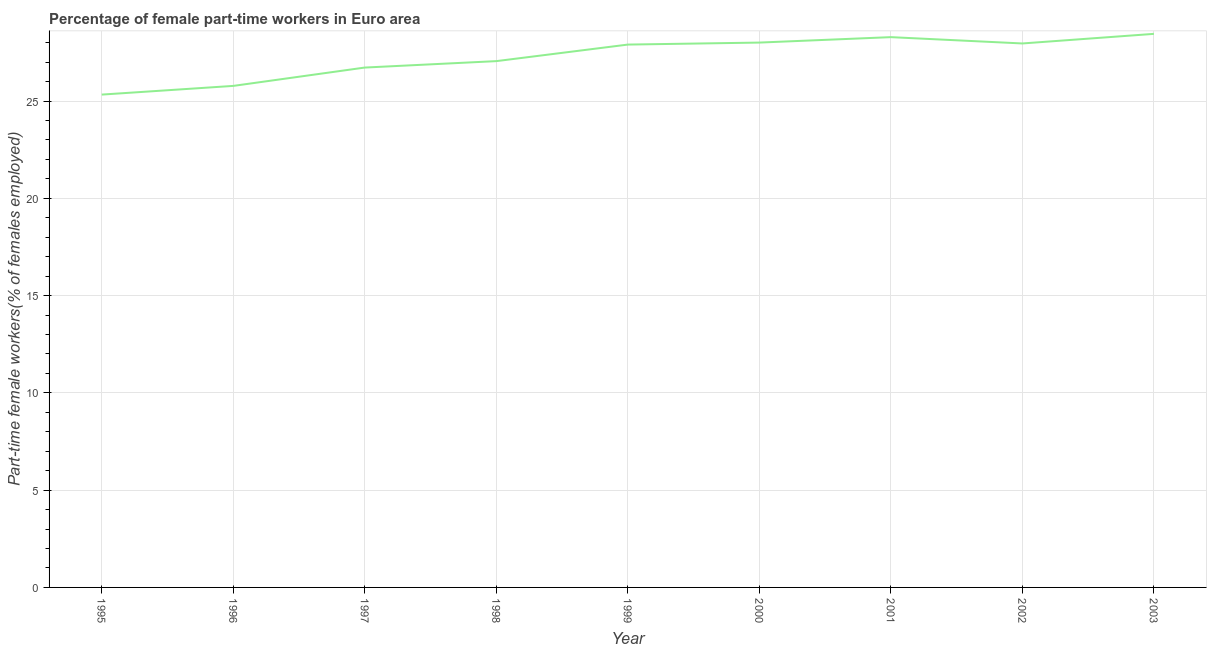What is the percentage of part-time female workers in 2003?
Your response must be concise. 28.45. Across all years, what is the maximum percentage of part-time female workers?
Provide a succinct answer. 28.45. Across all years, what is the minimum percentage of part-time female workers?
Make the answer very short. 25.33. In which year was the percentage of part-time female workers minimum?
Provide a succinct answer. 1995. What is the sum of the percentage of part-time female workers?
Offer a terse response. 245.49. What is the difference between the percentage of part-time female workers in 1999 and 2000?
Offer a very short reply. -0.1. What is the average percentage of part-time female workers per year?
Provide a succinct answer. 27.28. What is the median percentage of part-time female workers?
Offer a very short reply. 27.9. What is the ratio of the percentage of part-time female workers in 2001 to that in 2002?
Keep it short and to the point. 1.01. What is the difference between the highest and the second highest percentage of part-time female workers?
Keep it short and to the point. 0.17. What is the difference between the highest and the lowest percentage of part-time female workers?
Your response must be concise. 3.12. In how many years, is the percentage of part-time female workers greater than the average percentage of part-time female workers taken over all years?
Ensure brevity in your answer.  5. Does the percentage of part-time female workers monotonically increase over the years?
Your answer should be very brief. No. Does the graph contain any zero values?
Ensure brevity in your answer.  No. Does the graph contain grids?
Offer a very short reply. Yes. What is the title of the graph?
Offer a very short reply. Percentage of female part-time workers in Euro area. What is the label or title of the X-axis?
Your answer should be compact. Year. What is the label or title of the Y-axis?
Your answer should be compact. Part-time female workers(% of females employed). What is the Part-time female workers(% of females employed) of 1995?
Ensure brevity in your answer.  25.33. What is the Part-time female workers(% of females employed) in 1996?
Your answer should be very brief. 25.78. What is the Part-time female workers(% of females employed) of 1997?
Offer a terse response. 26.72. What is the Part-time female workers(% of females employed) in 1998?
Provide a short and direct response. 27.05. What is the Part-time female workers(% of females employed) of 1999?
Your answer should be compact. 27.9. What is the Part-time female workers(% of females employed) in 2000?
Your response must be concise. 28.01. What is the Part-time female workers(% of females employed) of 2001?
Ensure brevity in your answer.  28.28. What is the Part-time female workers(% of females employed) of 2002?
Offer a very short reply. 27.96. What is the Part-time female workers(% of females employed) of 2003?
Your response must be concise. 28.45. What is the difference between the Part-time female workers(% of females employed) in 1995 and 1996?
Your answer should be compact. -0.45. What is the difference between the Part-time female workers(% of females employed) in 1995 and 1997?
Your answer should be compact. -1.39. What is the difference between the Part-time female workers(% of females employed) in 1995 and 1998?
Provide a succinct answer. -1.72. What is the difference between the Part-time female workers(% of females employed) in 1995 and 1999?
Provide a succinct answer. -2.57. What is the difference between the Part-time female workers(% of females employed) in 1995 and 2000?
Your response must be concise. -2.67. What is the difference between the Part-time female workers(% of females employed) in 1995 and 2001?
Your answer should be compact. -2.95. What is the difference between the Part-time female workers(% of females employed) in 1995 and 2002?
Offer a very short reply. -2.63. What is the difference between the Part-time female workers(% of females employed) in 1995 and 2003?
Offer a very short reply. -3.12. What is the difference between the Part-time female workers(% of females employed) in 1996 and 1997?
Provide a succinct answer. -0.94. What is the difference between the Part-time female workers(% of females employed) in 1996 and 1998?
Your answer should be very brief. -1.27. What is the difference between the Part-time female workers(% of females employed) in 1996 and 1999?
Ensure brevity in your answer.  -2.12. What is the difference between the Part-time female workers(% of females employed) in 1996 and 2000?
Keep it short and to the point. -2.23. What is the difference between the Part-time female workers(% of females employed) in 1996 and 2001?
Provide a short and direct response. -2.51. What is the difference between the Part-time female workers(% of females employed) in 1996 and 2002?
Provide a short and direct response. -2.18. What is the difference between the Part-time female workers(% of females employed) in 1996 and 2003?
Offer a very short reply. -2.67. What is the difference between the Part-time female workers(% of females employed) in 1997 and 1998?
Ensure brevity in your answer.  -0.33. What is the difference between the Part-time female workers(% of females employed) in 1997 and 1999?
Provide a succinct answer. -1.18. What is the difference between the Part-time female workers(% of females employed) in 1997 and 2000?
Offer a terse response. -1.28. What is the difference between the Part-time female workers(% of females employed) in 1997 and 2001?
Make the answer very short. -1.56. What is the difference between the Part-time female workers(% of females employed) in 1997 and 2002?
Give a very brief answer. -1.24. What is the difference between the Part-time female workers(% of females employed) in 1997 and 2003?
Provide a succinct answer. -1.73. What is the difference between the Part-time female workers(% of females employed) in 1998 and 1999?
Keep it short and to the point. -0.85. What is the difference between the Part-time female workers(% of females employed) in 1998 and 2000?
Provide a succinct answer. -0.95. What is the difference between the Part-time female workers(% of females employed) in 1998 and 2001?
Your answer should be very brief. -1.23. What is the difference between the Part-time female workers(% of females employed) in 1998 and 2002?
Offer a terse response. -0.91. What is the difference between the Part-time female workers(% of females employed) in 1998 and 2003?
Keep it short and to the point. -1.4. What is the difference between the Part-time female workers(% of females employed) in 1999 and 2000?
Ensure brevity in your answer.  -0.1. What is the difference between the Part-time female workers(% of females employed) in 1999 and 2001?
Your answer should be compact. -0.38. What is the difference between the Part-time female workers(% of females employed) in 1999 and 2002?
Keep it short and to the point. -0.06. What is the difference between the Part-time female workers(% of females employed) in 1999 and 2003?
Your answer should be compact. -0.55. What is the difference between the Part-time female workers(% of females employed) in 2000 and 2001?
Make the answer very short. -0.28. What is the difference between the Part-time female workers(% of females employed) in 2000 and 2002?
Offer a terse response. 0.05. What is the difference between the Part-time female workers(% of females employed) in 2000 and 2003?
Offer a very short reply. -0.45. What is the difference between the Part-time female workers(% of females employed) in 2001 and 2002?
Make the answer very short. 0.33. What is the difference between the Part-time female workers(% of females employed) in 2001 and 2003?
Your answer should be compact. -0.17. What is the difference between the Part-time female workers(% of females employed) in 2002 and 2003?
Make the answer very short. -0.49. What is the ratio of the Part-time female workers(% of females employed) in 1995 to that in 1996?
Make the answer very short. 0.98. What is the ratio of the Part-time female workers(% of females employed) in 1995 to that in 1997?
Provide a short and direct response. 0.95. What is the ratio of the Part-time female workers(% of females employed) in 1995 to that in 1998?
Ensure brevity in your answer.  0.94. What is the ratio of the Part-time female workers(% of females employed) in 1995 to that in 1999?
Your response must be concise. 0.91. What is the ratio of the Part-time female workers(% of females employed) in 1995 to that in 2000?
Ensure brevity in your answer.  0.91. What is the ratio of the Part-time female workers(% of females employed) in 1995 to that in 2001?
Provide a succinct answer. 0.9. What is the ratio of the Part-time female workers(% of females employed) in 1995 to that in 2002?
Offer a very short reply. 0.91. What is the ratio of the Part-time female workers(% of females employed) in 1995 to that in 2003?
Offer a very short reply. 0.89. What is the ratio of the Part-time female workers(% of females employed) in 1996 to that in 1997?
Your answer should be compact. 0.96. What is the ratio of the Part-time female workers(% of females employed) in 1996 to that in 1998?
Provide a short and direct response. 0.95. What is the ratio of the Part-time female workers(% of females employed) in 1996 to that in 1999?
Provide a short and direct response. 0.92. What is the ratio of the Part-time female workers(% of females employed) in 1996 to that in 2000?
Provide a succinct answer. 0.92. What is the ratio of the Part-time female workers(% of females employed) in 1996 to that in 2001?
Your answer should be compact. 0.91. What is the ratio of the Part-time female workers(% of females employed) in 1996 to that in 2002?
Offer a terse response. 0.92. What is the ratio of the Part-time female workers(% of females employed) in 1996 to that in 2003?
Offer a terse response. 0.91. What is the ratio of the Part-time female workers(% of females employed) in 1997 to that in 1998?
Provide a short and direct response. 0.99. What is the ratio of the Part-time female workers(% of females employed) in 1997 to that in 1999?
Provide a succinct answer. 0.96. What is the ratio of the Part-time female workers(% of females employed) in 1997 to that in 2000?
Your response must be concise. 0.95. What is the ratio of the Part-time female workers(% of females employed) in 1997 to that in 2001?
Ensure brevity in your answer.  0.94. What is the ratio of the Part-time female workers(% of females employed) in 1997 to that in 2002?
Make the answer very short. 0.96. What is the ratio of the Part-time female workers(% of females employed) in 1997 to that in 2003?
Your response must be concise. 0.94. What is the ratio of the Part-time female workers(% of females employed) in 1998 to that in 2000?
Keep it short and to the point. 0.97. What is the ratio of the Part-time female workers(% of females employed) in 1998 to that in 2001?
Keep it short and to the point. 0.96. What is the ratio of the Part-time female workers(% of females employed) in 1998 to that in 2002?
Your answer should be very brief. 0.97. What is the ratio of the Part-time female workers(% of females employed) in 1998 to that in 2003?
Your answer should be very brief. 0.95. What is the ratio of the Part-time female workers(% of females employed) in 1999 to that in 2000?
Offer a very short reply. 1. What is the ratio of the Part-time female workers(% of females employed) in 1999 to that in 2001?
Your response must be concise. 0.99. What is the ratio of the Part-time female workers(% of females employed) in 1999 to that in 2003?
Offer a terse response. 0.98. What is the ratio of the Part-time female workers(% of females employed) in 2000 to that in 2001?
Keep it short and to the point. 0.99. What is the ratio of the Part-time female workers(% of females employed) in 2000 to that in 2002?
Your response must be concise. 1. 